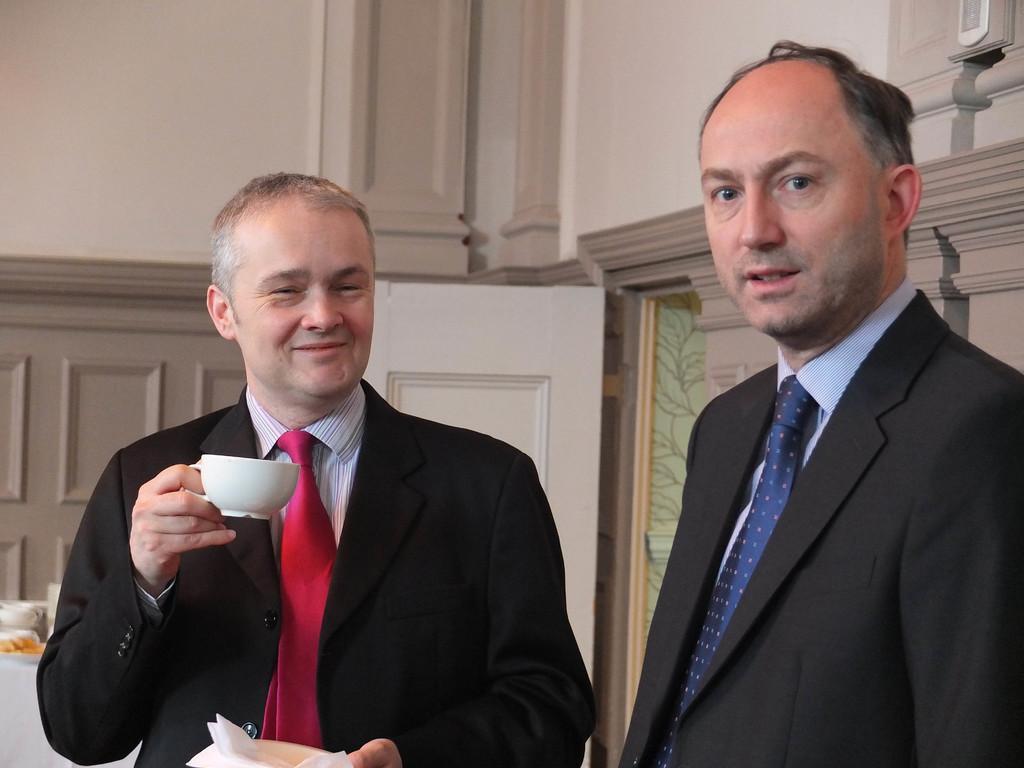Can you describe this image briefly? In this image I see 2 men who are wearing black suits and I see that this man is smiling and I see that he is holding a white cup in one hand and white tissues in other hand. In the background I see the wall and I see the white door over here. 